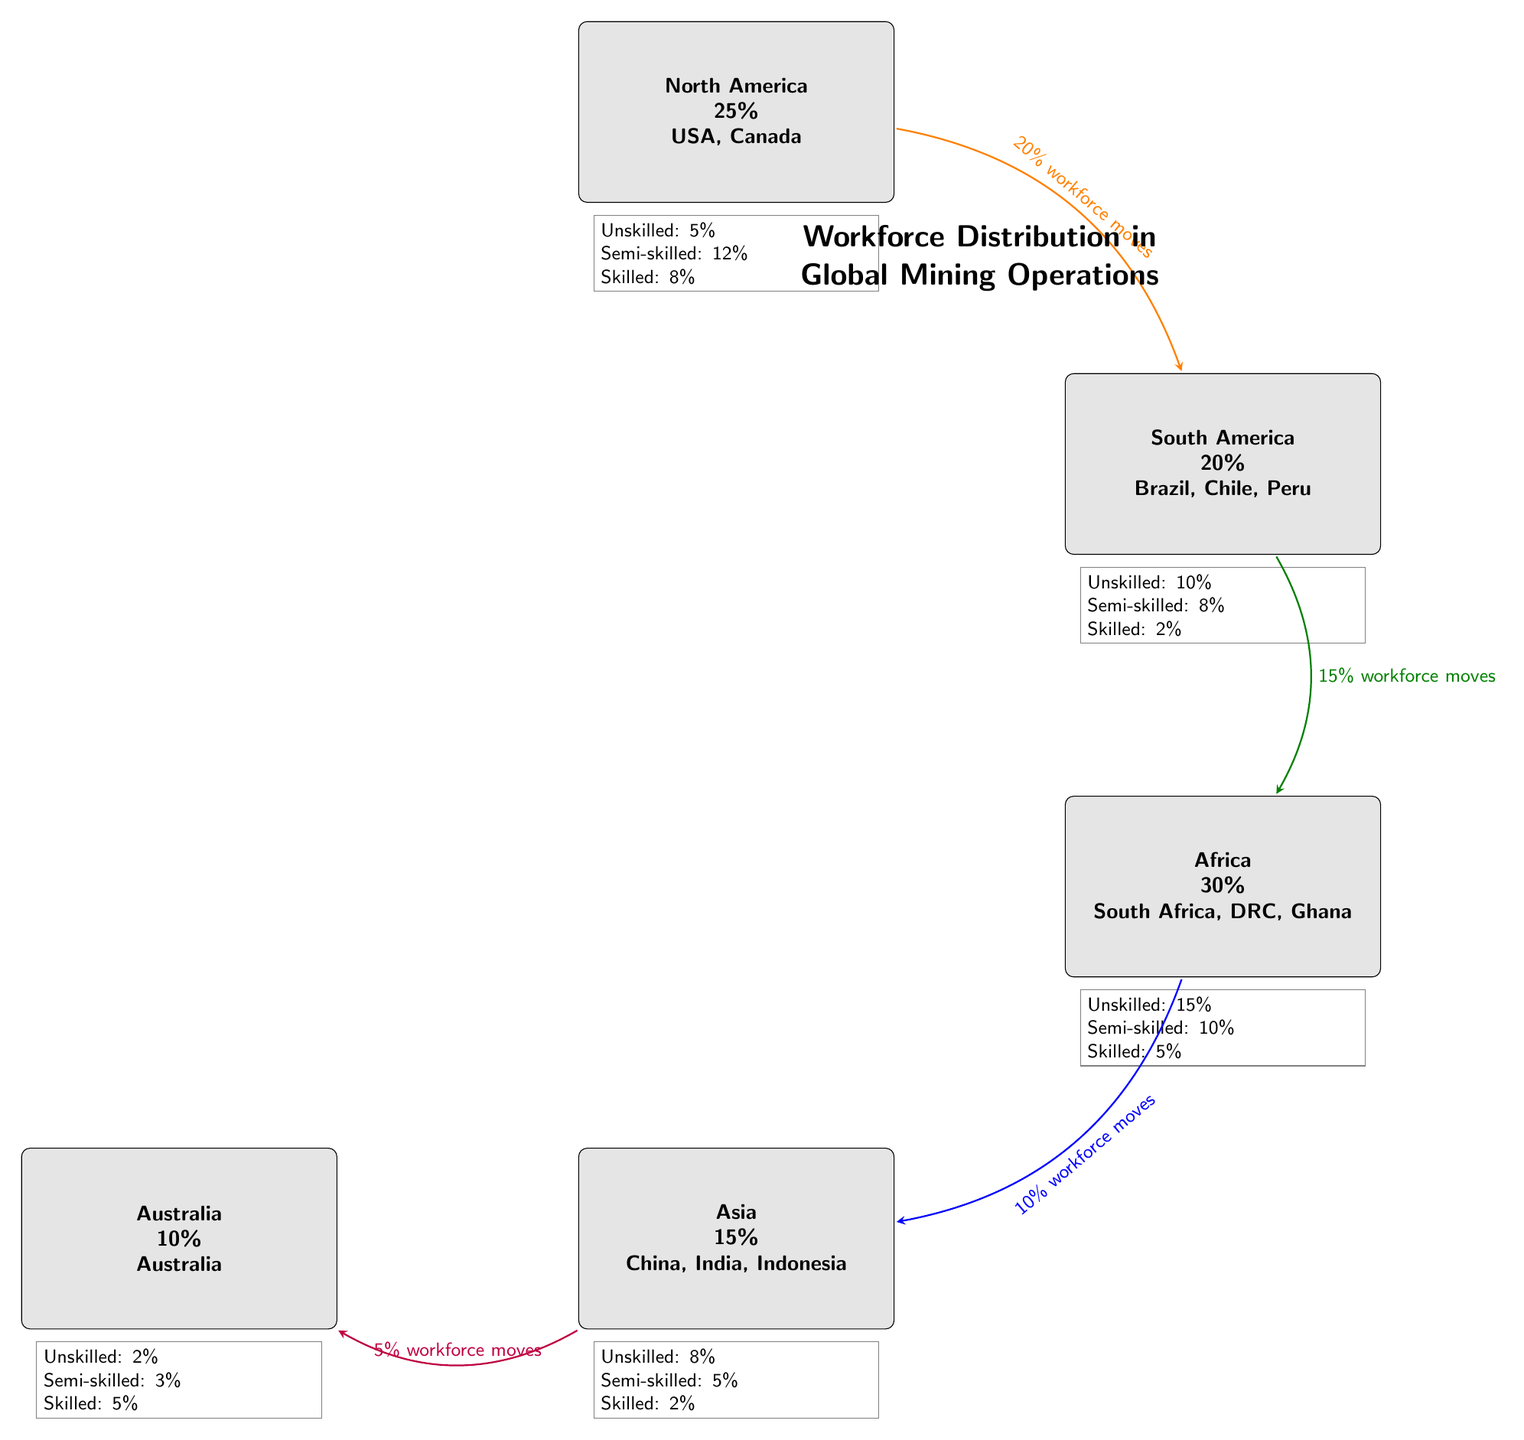What percentage of the workforce in Africa is unskilled? The diagram shows that the percentage of the unskilled workforce in Africa is specifically stated in the skill level box directly below the Africa region node. The value indicated is 15%.
Answer: 15% Which region has the highest percentage of skilled workers? By analyzing the skill boxes associated with each region, Africa has the highest percentage of skilled workers at 5%, compared to other regions like North America (8%), South America (2%), Asia (2%), and Australia (5%). Therefore, we note that North America leads in skilled workforce at 8%.
Answer: North America What is the percentage of the workforce that moves from South America to Africa? The diagram features an arrow representing the workforce movement from South America to Africa, with the label indicating a 15% transition. This value is visually highlighted on the diagram at the connection between the two regions.
Answer: 15% How many total regions are represented in the diagram? The regions depicted in the diagram include North America, South America, Africa, Asia, and Australia. By counting these nodes, we confirm there are five distinct regions outlined in the visual.
Answer: 5 What percentage of skilled workers is found in Asia? As outlined in the skill level box beneath the Asia region, the percentage of skilled workers is clearly indicated. The data points to only 2% of the workforce in Asia being classified as skilled.
Answer: 2% Which region has the lowest total workforce percentage? Upon reviewing the various workforce percentages attributed to each region, Australia has the lowest representation at 10%. This percentage is visually positioned within the corresponding rectangular node for easy identification.
Answer: Australia 